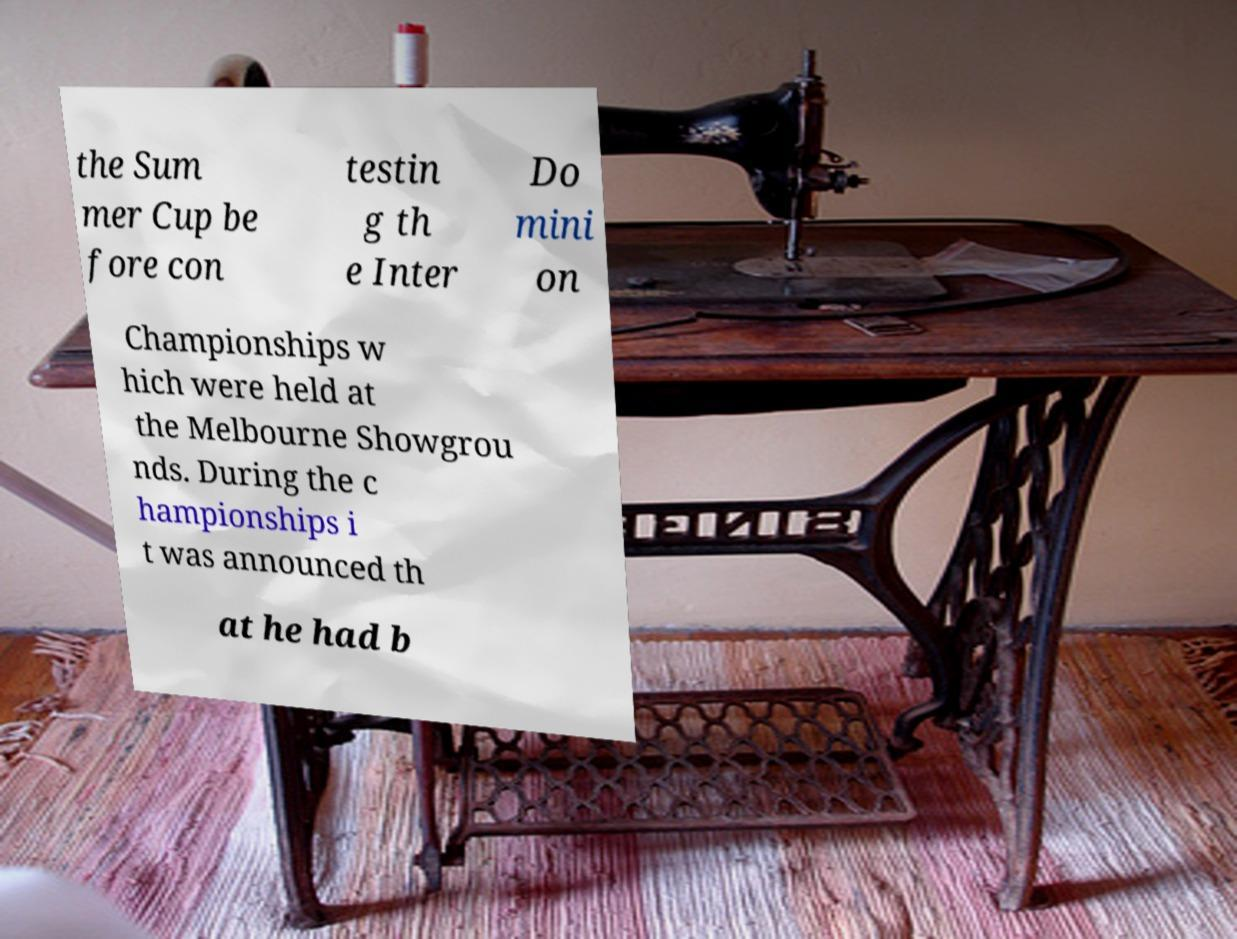Can you read and provide the text displayed in the image?This photo seems to have some interesting text. Can you extract and type it out for me? the Sum mer Cup be fore con testin g th e Inter Do mini on Championships w hich were held at the Melbourne Showgrou nds. During the c hampionships i t was announced th at he had b 